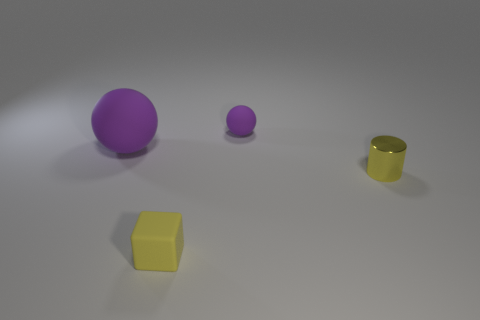How many objects are there in total, and can you describe their shapes? There are four objects in total. Starting from the left, there is a large purple sphere, a smaller purple sphere, a yellow cylinder, and a yellow cube. 